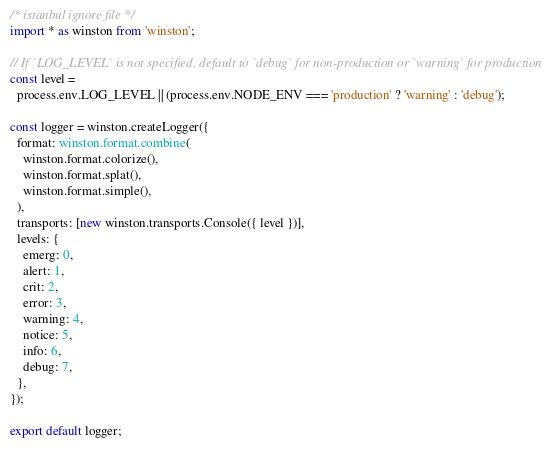Convert code to text. <code><loc_0><loc_0><loc_500><loc_500><_TypeScript_>/* istanbul ignore file */
import * as winston from 'winston';

// If `LOG_LEVEL` is not specified, default to `debug` for non-production or `warning` for production
const level =
  process.env.LOG_LEVEL || (process.env.NODE_ENV === 'production' ? 'warning' : 'debug');

const logger = winston.createLogger({
  format: winston.format.combine(
    winston.format.colorize(),
    winston.format.splat(),
    winston.format.simple(),
  ),
  transports: [new winston.transports.Console({ level })],
  levels: {
    emerg: 0,
    alert: 1,
    crit: 2,
    error: 3,
    warning: 4,
    notice: 5,
    info: 6,
    debug: 7,
  },
});

export default logger;
</code> 